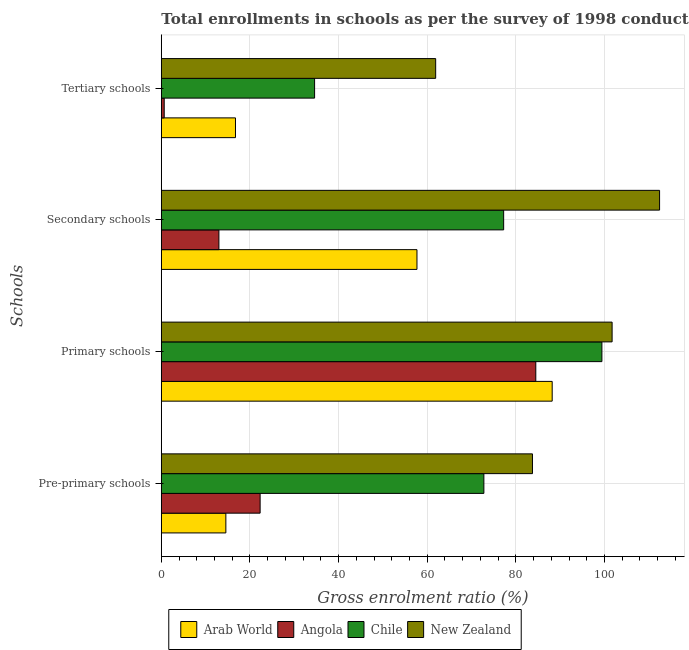Are the number of bars on each tick of the Y-axis equal?
Keep it short and to the point. Yes. How many bars are there on the 1st tick from the bottom?
Your answer should be compact. 4. What is the label of the 2nd group of bars from the top?
Make the answer very short. Secondary schools. What is the gross enrolment ratio in pre-primary schools in Angola?
Your answer should be very brief. 22.3. Across all countries, what is the maximum gross enrolment ratio in pre-primary schools?
Your answer should be compact. 83.75. Across all countries, what is the minimum gross enrolment ratio in primary schools?
Give a very brief answer. 84.5. In which country was the gross enrolment ratio in tertiary schools maximum?
Provide a short and direct response. New Zealand. In which country was the gross enrolment ratio in primary schools minimum?
Give a very brief answer. Angola. What is the total gross enrolment ratio in tertiary schools in the graph?
Your answer should be compact. 113.89. What is the difference between the gross enrolment ratio in tertiary schools in Arab World and that in Angola?
Give a very brief answer. 16.08. What is the difference between the gross enrolment ratio in tertiary schools in New Zealand and the gross enrolment ratio in primary schools in Chile?
Give a very brief answer. -37.51. What is the average gross enrolment ratio in pre-primary schools per country?
Make the answer very short. 48.35. What is the difference between the gross enrolment ratio in pre-primary schools and gross enrolment ratio in tertiary schools in Angola?
Provide a short and direct response. 21.64. In how many countries, is the gross enrolment ratio in pre-primary schools greater than 92 %?
Offer a terse response. 0. What is the ratio of the gross enrolment ratio in primary schools in New Zealand to that in Arab World?
Provide a succinct answer. 1.15. Is the gross enrolment ratio in secondary schools in New Zealand less than that in Chile?
Give a very brief answer. No. Is the difference between the gross enrolment ratio in primary schools in Angola and Arab World greater than the difference between the gross enrolment ratio in secondary schools in Angola and Arab World?
Your response must be concise. Yes. What is the difference between the highest and the second highest gross enrolment ratio in tertiary schools?
Your answer should be very brief. 27.32. What is the difference between the highest and the lowest gross enrolment ratio in secondary schools?
Your response must be concise. 99.44. In how many countries, is the gross enrolment ratio in primary schools greater than the average gross enrolment ratio in primary schools taken over all countries?
Keep it short and to the point. 2. Is it the case that in every country, the sum of the gross enrolment ratio in primary schools and gross enrolment ratio in secondary schools is greater than the sum of gross enrolment ratio in pre-primary schools and gross enrolment ratio in tertiary schools?
Provide a short and direct response. Yes. What does the 4th bar from the top in Primary schools represents?
Your answer should be very brief. Arab World. What does the 2nd bar from the bottom in Primary schools represents?
Your response must be concise. Angola. Is it the case that in every country, the sum of the gross enrolment ratio in pre-primary schools and gross enrolment ratio in primary schools is greater than the gross enrolment ratio in secondary schools?
Ensure brevity in your answer.  Yes. Are all the bars in the graph horizontal?
Your response must be concise. Yes. What is the difference between two consecutive major ticks on the X-axis?
Make the answer very short. 20. Does the graph contain grids?
Ensure brevity in your answer.  Yes. Where does the legend appear in the graph?
Make the answer very short. Bottom center. How many legend labels are there?
Ensure brevity in your answer.  4. How are the legend labels stacked?
Ensure brevity in your answer.  Horizontal. What is the title of the graph?
Your answer should be very brief. Total enrollments in schools as per the survey of 1998 conducted in different countries. What is the label or title of the X-axis?
Ensure brevity in your answer.  Gross enrolment ratio (%). What is the label or title of the Y-axis?
Offer a terse response. Schools. What is the Gross enrolment ratio (%) in Arab World in Pre-primary schools?
Ensure brevity in your answer.  14.56. What is the Gross enrolment ratio (%) of Angola in Pre-primary schools?
Your answer should be compact. 22.3. What is the Gross enrolment ratio (%) in Chile in Pre-primary schools?
Offer a terse response. 72.79. What is the Gross enrolment ratio (%) of New Zealand in Pre-primary schools?
Keep it short and to the point. 83.75. What is the Gross enrolment ratio (%) in Arab World in Primary schools?
Make the answer very short. 88.2. What is the Gross enrolment ratio (%) of Angola in Primary schools?
Give a very brief answer. 84.5. What is the Gross enrolment ratio (%) of Chile in Primary schools?
Provide a short and direct response. 99.42. What is the Gross enrolment ratio (%) in New Zealand in Primary schools?
Ensure brevity in your answer.  101.72. What is the Gross enrolment ratio (%) of Arab World in Secondary schools?
Offer a very short reply. 57.69. What is the Gross enrolment ratio (%) of Angola in Secondary schools?
Keep it short and to the point. 12.99. What is the Gross enrolment ratio (%) in Chile in Secondary schools?
Offer a very short reply. 77.25. What is the Gross enrolment ratio (%) in New Zealand in Secondary schools?
Your response must be concise. 112.43. What is the Gross enrolment ratio (%) in Arab World in Tertiary schools?
Give a very brief answer. 16.74. What is the Gross enrolment ratio (%) in Angola in Tertiary schools?
Your response must be concise. 0.65. What is the Gross enrolment ratio (%) in Chile in Tertiary schools?
Give a very brief answer. 34.59. What is the Gross enrolment ratio (%) of New Zealand in Tertiary schools?
Your answer should be very brief. 61.91. Across all Schools, what is the maximum Gross enrolment ratio (%) of Arab World?
Give a very brief answer. 88.2. Across all Schools, what is the maximum Gross enrolment ratio (%) in Angola?
Provide a short and direct response. 84.5. Across all Schools, what is the maximum Gross enrolment ratio (%) of Chile?
Keep it short and to the point. 99.42. Across all Schools, what is the maximum Gross enrolment ratio (%) of New Zealand?
Provide a short and direct response. 112.43. Across all Schools, what is the minimum Gross enrolment ratio (%) of Arab World?
Offer a terse response. 14.56. Across all Schools, what is the minimum Gross enrolment ratio (%) of Angola?
Your answer should be compact. 0.65. Across all Schools, what is the minimum Gross enrolment ratio (%) in Chile?
Provide a short and direct response. 34.59. Across all Schools, what is the minimum Gross enrolment ratio (%) in New Zealand?
Provide a succinct answer. 61.91. What is the total Gross enrolment ratio (%) of Arab World in the graph?
Provide a succinct answer. 177.19. What is the total Gross enrolment ratio (%) of Angola in the graph?
Provide a succinct answer. 120.45. What is the total Gross enrolment ratio (%) of Chile in the graph?
Your response must be concise. 284.04. What is the total Gross enrolment ratio (%) in New Zealand in the graph?
Your response must be concise. 359.81. What is the difference between the Gross enrolment ratio (%) in Arab World in Pre-primary schools and that in Primary schools?
Keep it short and to the point. -73.64. What is the difference between the Gross enrolment ratio (%) of Angola in Pre-primary schools and that in Primary schools?
Offer a very short reply. -62.2. What is the difference between the Gross enrolment ratio (%) in Chile in Pre-primary schools and that in Primary schools?
Your response must be concise. -26.63. What is the difference between the Gross enrolment ratio (%) of New Zealand in Pre-primary schools and that in Primary schools?
Ensure brevity in your answer.  -17.97. What is the difference between the Gross enrolment ratio (%) of Arab World in Pre-primary schools and that in Secondary schools?
Your answer should be compact. -43.12. What is the difference between the Gross enrolment ratio (%) of Angola in Pre-primary schools and that in Secondary schools?
Your answer should be compact. 9.3. What is the difference between the Gross enrolment ratio (%) of Chile in Pre-primary schools and that in Secondary schools?
Your answer should be very brief. -4.46. What is the difference between the Gross enrolment ratio (%) of New Zealand in Pre-primary schools and that in Secondary schools?
Offer a very short reply. -28.68. What is the difference between the Gross enrolment ratio (%) in Arab World in Pre-primary schools and that in Tertiary schools?
Provide a short and direct response. -2.17. What is the difference between the Gross enrolment ratio (%) of Angola in Pre-primary schools and that in Tertiary schools?
Offer a very short reply. 21.64. What is the difference between the Gross enrolment ratio (%) in Chile in Pre-primary schools and that in Tertiary schools?
Your answer should be very brief. 38.2. What is the difference between the Gross enrolment ratio (%) in New Zealand in Pre-primary schools and that in Tertiary schools?
Ensure brevity in your answer.  21.84. What is the difference between the Gross enrolment ratio (%) of Arab World in Primary schools and that in Secondary schools?
Offer a very short reply. 30.51. What is the difference between the Gross enrolment ratio (%) of Angola in Primary schools and that in Secondary schools?
Ensure brevity in your answer.  71.51. What is the difference between the Gross enrolment ratio (%) in Chile in Primary schools and that in Secondary schools?
Make the answer very short. 22.17. What is the difference between the Gross enrolment ratio (%) of New Zealand in Primary schools and that in Secondary schools?
Provide a short and direct response. -10.71. What is the difference between the Gross enrolment ratio (%) in Arab World in Primary schools and that in Tertiary schools?
Keep it short and to the point. 71.46. What is the difference between the Gross enrolment ratio (%) of Angola in Primary schools and that in Tertiary schools?
Keep it short and to the point. 83.85. What is the difference between the Gross enrolment ratio (%) in Chile in Primary schools and that in Tertiary schools?
Provide a short and direct response. 64.83. What is the difference between the Gross enrolment ratio (%) in New Zealand in Primary schools and that in Tertiary schools?
Your answer should be compact. 39.81. What is the difference between the Gross enrolment ratio (%) of Arab World in Secondary schools and that in Tertiary schools?
Provide a succinct answer. 40.95. What is the difference between the Gross enrolment ratio (%) of Angola in Secondary schools and that in Tertiary schools?
Your answer should be compact. 12.34. What is the difference between the Gross enrolment ratio (%) in Chile in Secondary schools and that in Tertiary schools?
Give a very brief answer. 42.66. What is the difference between the Gross enrolment ratio (%) of New Zealand in Secondary schools and that in Tertiary schools?
Offer a very short reply. 50.52. What is the difference between the Gross enrolment ratio (%) of Arab World in Pre-primary schools and the Gross enrolment ratio (%) of Angola in Primary schools?
Provide a short and direct response. -69.94. What is the difference between the Gross enrolment ratio (%) in Arab World in Pre-primary schools and the Gross enrolment ratio (%) in Chile in Primary schools?
Give a very brief answer. -84.85. What is the difference between the Gross enrolment ratio (%) of Arab World in Pre-primary schools and the Gross enrolment ratio (%) of New Zealand in Primary schools?
Your response must be concise. -87.15. What is the difference between the Gross enrolment ratio (%) in Angola in Pre-primary schools and the Gross enrolment ratio (%) in Chile in Primary schools?
Your answer should be very brief. -77.12. What is the difference between the Gross enrolment ratio (%) of Angola in Pre-primary schools and the Gross enrolment ratio (%) of New Zealand in Primary schools?
Keep it short and to the point. -79.42. What is the difference between the Gross enrolment ratio (%) in Chile in Pre-primary schools and the Gross enrolment ratio (%) in New Zealand in Primary schools?
Provide a short and direct response. -28.93. What is the difference between the Gross enrolment ratio (%) of Arab World in Pre-primary schools and the Gross enrolment ratio (%) of Angola in Secondary schools?
Your answer should be very brief. 1.57. What is the difference between the Gross enrolment ratio (%) of Arab World in Pre-primary schools and the Gross enrolment ratio (%) of Chile in Secondary schools?
Provide a short and direct response. -62.69. What is the difference between the Gross enrolment ratio (%) of Arab World in Pre-primary schools and the Gross enrolment ratio (%) of New Zealand in Secondary schools?
Make the answer very short. -97.87. What is the difference between the Gross enrolment ratio (%) in Angola in Pre-primary schools and the Gross enrolment ratio (%) in Chile in Secondary schools?
Your response must be concise. -54.95. What is the difference between the Gross enrolment ratio (%) in Angola in Pre-primary schools and the Gross enrolment ratio (%) in New Zealand in Secondary schools?
Your answer should be compact. -90.14. What is the difference between the Gross enrolment ratio (%) in Chile in Pre-primary schools and the Gross enrolment ratio (%) in New Zealand in Secondary schools?
Your response must be concise. -39.65. What is the difference between the Gross enrolment ratio (%) in Arab World in Pre-primary schools and the Gross enrolment ratio (%) in Angola in Tertiary schools?
Provide a short and direct response. 13.91. What is the difference between the Gross enrolment ratio (%) in Arab World in Pre-primary schools and the Gross enrolment ratio (%) in Chile in Tertiary schools?
Offer a terse response. -20.02. What is the difference between the Gross enrolment ratio (%) of Arab World in Pre-primary schools and the Gross enrolment ratio (%) of New Zealand in Tertiary schools?
Provide a short and direct response. -47.34. What is the difference between the Gross enrolment ratio (%) in Angola in Pre-primary schools and the Gross enrolment ratio (%) in Chile in Tertiary schools?
Offer a terse response. -12.29. What is the difference between the Gross enrolment ratio (%) of Angola in Pre-primary schools and the Gross enrolment ratio (%) of New Zealand in Tertiary schools?
Ensure brevity in your answer.  -39.61. What is the difference between the Gross enrolment ratio (%) in Chile in Pre-primary schools and the Gross enrolment ratio (%) in New Zealand in Tertiary schools?
Make the answer very short. 10.88. What is the difference between the Gross enrolment ratio (%) in Arab World in Primary schools and the Gross enrolment ratio (%) in Angola in Secondary schools?
Your response must be concise. 75.21. What is the difference between the Gross enrolment ratio (%) in Arab World in Primary schools and the Gross enrolment ratio (%) in Chile in Secondary schools?
Your answer should be very brief. 10.95. What is the difference between the Gross enrolment ratio (%) of Arab World in Primary schools and the Gross enrolment ratio (%) of New Zealand in Secondary schools?
Provide a short and direct response. -24.23. What is the difference between the Gross enrolment ratio (%) of Angola in Primary schools and the Gross enrolment ratio (%) of Chile in Secondary schools?
Make the answer very short. 7.25. What is the difference between the Gross enrolment ratio (%) in Angola in Primary schools and the Gross enrolment ratio (%) in New Zealand in Secondary schools?
Provide a short and direct response. -27.93. What is the difference between the Gross enrolment ratio (%) in Chile in Primary schools and the Gross enrolment ratio (%) in New Zealand in Secondary schools?
Your answer should be compact. -13.01. What is the difference between the Gross enrolment ratio (%) of Arab World in Primary schools and the Gross enrolment ratio (%) of Angola in Tertiary schools?
Your answer should be very brief. 87.55. What is the difference between the Gross enrolment ratio (%) of Arab World in Primary schools and the Gross enrolment ratio (%) of Chile in Tertiary schools?
Ensure brevity in your answer.  53.61. What is the difference between the Gross enrolment ratio (%) in Arab World in Primary schools and the Gross enrolment ratio (%) in New Zealand in Tertiary schools?
Your response must be concise. 26.29. What is the difference between the Gross enrolment ratio (%) in Angola in Primary schools and the Gross enrolment ratio (%) in Chile in Tertiary schools?
Keep it short and to the point. 49.92. What is the difference between the Gross enrolment ratio (%) of Angola in Primary schools and the Gross enrolment ratio (%) of New Zealand in Tertiary schools?
Ensure brevity in your answer.  22.59. What is the difference between the Gross enrolment ratio (%) in Chile in Primary schools and the Gross enrolment ratio (%) in New Zealand in Tertiary schools?
Give a very brief answer. 37.51. What is the difference between the Gross enrolment ratio (%) of Arab World in Secondary schools and the Gross enrolment ratio (%) of Angola in Tertiary schools?
Ensure brevity in your answer.  57.03. What is the difference between the Gross enrolment ratio (%) in Arab World in Secondary schools and the Gross enrolment ratio (%) in Chile in Tertiary schools?
Provide a succinct answer. 23.1. What is the difference between the Gross enrolment ratio (%) of Arab World in Secondary schools and the Gross enrolment ratio (%) of New Zealand in Tertiary schools?
Your response must be concise. -4.22. What is the difference between the Gross enrolment ratio (%) in Angola in Secondary schools and the Gross enrolment ratio (%) in Chile in Tertiary schools?
Provide a succinct answer. -21.59. What is the difference between the Gross enrolment ratio (%) in Angola in Secondary schools and the Gross enrolment ratio (%) in New Zealand in Tertiary schools?
Keep it short and to the point. -48.91. What is the difference between the Gross enrolment ratio (%) of Chile in Secondary schools and the Gross enrolment ratio (%) of New Zealand in Tertiary schools?
Offer a terse response. 15.34. What is the average Gross enrolment ratio (%) of Arab World per Schools?
Make the answer very short. 44.3. What is the average Gross enrolment ratio (%) of Angola per Schools?
Your answer should be compact. 30.11. What is the average Gross enrolment ratio (%) of Chile per Schools?
Provide a short and direct response. 71.01. What is the average Gross enrolment ratio (%) in New Zealand per Schools?
Offer a very short reply. 89.95. What is the difference between the Gross enrolment ratio (%) in Arab World and Gross enrolment ratio (%) in Angola in Pre-primary schools?
Give a very brief answer. -7.73. What is the difference between the Gross enrolment ratio (%) in Arab World and Gross enrolment ratio (%) in Chile in Pre-primary schools?
Ensure brevity in your answer.  -58.22. What is the difference between the Gross enrolment ratio (%) in Arab World and Gross enrolment ratio (%) in New Zealand in Pre-primary schools?
Your response must be concise. -69.18. What is the difference between the Gross enrolment ratio (%) of Angola and Gross enrolment ratio (%) of Chile in Pre-primary schools?
Offer a terse response. -50.49. What is the difference between the Gross enrolment ratio (%) of Angola and Gross enrolment ratio (%) of New Zealand in Pre-primary schools?
Ensure brevity in your answer.  -61.45. What is the difference between the Gross enrolment ratio (%) of Chile and Gross enrolment ratio (%) of New Zealand in Pre-primary schools?
Provide a succinct answer. -10.96. What is the difference between the Gross enrolment ratio (%) in Arab World and Gross enrolment ratio (%) in Angola in Primary schools?
Provide a succinct answer. 3.7. What is the difference between the Gross enrolment ratio (%) of Arab World and Gross enrolment ratio (%) of Chile in Primary schools?
Your response must be concise. -11.22. What is the difference between the Gross enrolment ratio (%) of Arab World and Gross enrolment ratio (%) of New Zealand in Primary schools?
Your answer should be very brief. -13.52. What is the difference between the Gross enrolment ratio (%) of Angola and Gross enrolment ratio (%) of Chile in Primary schools?
Give a very brief answer. -14.92. What is the difference between the Gross enrolment ratio (%) of Angola and Gross enrolment ratio (%) of New Zealand in Primary schools?
Give a very brief answer. -17.22. What is the difference between the Gross enrolment ratio (%) in Chile and Gross enrolment ratio (%) in New Zealand in Primary schools?
Make the answer very short. -2.3. What is the difference between the Gross enrolment ratio (%) of Arab World and Gross enrolment ratio (%) of Angola in Secondary schools?
Make the answer very short. 44.69. What is the difference between the Gross enrolment ratio (%) in Arab World and Gross enrolment ratio (%) in Chile in Secondary schools?
Provide a short and direct response. -19.56. What is the difference between the Gross enrolment ratio (%) of Arab World and Gross enrolment ratio (%) of New Zealand in Secondary schools?
Offer a very short reply. -54.75. What is the difference between the Gross enrolment ratio (%) in Angola and Gross enrolment ratio (%) in Chile in Secondary schools?
Your answer should be very brief. -64.26. What is the difference between the Gross enrolment ratio (%) of Angola and Gross enrolment ratio (%) of New Zealand in Secondary schools?
Offer a very short reply. -99.44. What is the difference between the Gross enrolment ratio (%) in Chile and Gross enrolment ratio (%) in New Zealand in Secondary schools?
Your answer should be very brief. -35.18. What is the difference between the Gross enrolment ratio (%) in Arab World and Gross enrolment ratio (%) in Angola in Tertiary schools?
Your response must be concise. 16.08. What is the difference between the Gross enrolment ratio (%) of Arab World and Gross enrolment ratio (%) of Chile in Tertiary schools?
Ensure brevity in your answer.  -17.85. What is the difference between the Gross enrolment ratio (%) in Arab World and Gross enrolment ratio (%) in New Zealand in Tertiary schools?
Give a very brief answer. -45.17. What is the difference between the Gross enrolment ratio (%) of Angola and Gross enrolment ratio (%) of Chile in Tertiary schools?
Ensure brevity in your answer.  -33.93. What is the difference between the Gross enrolment ratio (%) in Angola and Gross enrolment ratio (%) in New Zealand in Tertiary schools?
Your response must be concise. -61.25. What is the difference between the Gross enrolment ratio (%) in Chile and Gross enrolment ratio (%) in New Zealand in Tertiary schools?
Keep it short and to the point. -27.32. What is the ratio of the Gross enrolment ratio (%) in Arab World in Pre-primary schools to that in Primary schools?
Offer a very short reply. 0.17. What is the ratio of the Gross enrolment ratio (%) of Angola in Pre-primary schools to that in Primary schools?
Offer a terse response. 0.26. What is the ratio of the Gross enrolment ratio (%) of Chile in Pre-primary schools to that in Primary schools?
Offer a terse response. 0.73. What is the ratio of the Gross enrolment ratio (%) of New Zealand in Pre-primary schools to that in Primary schools?
Offer a very short reply. 0.82. What is the ratio of the Gross enrolment ratio (%) of Arab World in Pre-primary schools to that in Secondary schools?
Offer a terse response. 0.25. What is the ratio of the Gross enrolment ratio (%) of Angola in Pre-primary schools to that in Secondary schools?
Provide a succinct answer. 1.72. What is the ratio of the Gross enrolment ratio (%) in Chile in Pre-primary schools to that in Secondary schools?
Make the answer very short. 0.94. What is the ratio of the Gross enrolment ratio (%) of New Zealand in Pre-primary schools to that in Secondary schools?
Offer a very short reply. 0.74. What is the ratio of the Gross enrolment ratio (%) in Arab World in Pre-primary schools to that in Tertiary schools?
Your response must be concise. 0.87. What is the ratio of the Gross enrolment ratio (%) of Angola in Pre-primary schools to that in Tertiary schools?
Provide a succinct answer. 34.12. What is the ratio of the Gross enrolment ratio (%) of Chile in Pre-primary schools to that in Tertiary schools?
Your answer should be compact. 2.1. What is the ratio of the Gross enrolment ratio (%) of New Zealand in Pre-primary schools to that in Tertiary schools?
Give a very brief answer. 1.35. What is the ratio of the Gross enrolment ratio (%) in Arab World in Primary schools to that in Secondary schools?
Give a very brief answer. 1.53. What is the ratio of the Gross enrolment ratio (%) of Angola in Primary schools to that in Secondary schools?
Ensure brevity in your answer.  6.5. What is the ratio of the Gross enrolment ratio (%) in Chile in Primary schools to that in Secondary schools?
Offer a terse response. 1.29. What is the ratio of the Gross enrolment ratio (%) in New Zealand in Primary schools to that in Secondary schools?
Offer a terse response. 0.9. What is the ratio of the Gross enrolment ratio (%) of Arab World in Primary schools to that in Tertiary schools?
Your answer should be compact. 5.27. What is the ratio of the Gross enrolment ratio (%) in Angola in Primary schools to that in Tertiary schools?
Offer a terse response. 129.29. What is the ratio of the Gross enrolment ratio (%) in Chile in Primary schools to that in Tertiary schools?
Offer a very short reply. 2.87. What is the ratio of the Gross enrolment ratio (%) of New Zealand in Primary schools to that in Tertiary schools?
Provide a succinct answer. 1.64. What is the ratio of the Gross enrolment ratio (%) in Arab World in Secondary schools to that in Tertiary schools?
Provide a short and direct response. 3.45. What is the ratio of the Gross enrolment ratio (%) of Angola in Secondary schools to that in Tertiary schools?
Your response must be concise. 19.88. What is the ratio of the Gross enrolment ratio (%) in Chile in Secondary schools to that in Tertiary schools?
Your response must be concise. 2.23. What is the ratio of the Gross enrolment ratio (%) of New Zealand in Secondary schools to that in Tertiary schools?
Your answer should be compact. 1.82. What is the difference between the highest and the second highest Gross enrolment ratio (%) of Arab World?
Your answer should be very brief. 30.51. What is the difference between the highest and the second highest Gross enrolment ratio (%) of Angola?
Your response must be concise. 62.2. What is the difference between the highest and the second highest Gross enrolment ratio (%) of Chile?
Make the answer very short. 22.17. What is the difference between the highest and the second highest Gross enrolment ratio (%) of New Zealand?
Make the answer very short. 10.71. What is the difference between the highest and the lowest Gross enrolment ratio (%) in Arab World?
Your answer should be compact. 73.64. What is the difference between the highest and the lowest Gross enrolment ratio (%) of Angola?
Your answer should be very brief. 83.85. What is the difference between the highest and the lowest Gross enrolment ratio (%) of Chile?
Provide a short and direct response. 64.83. What is the difference between the highest and the lowest Gross enrolment ratio (%) in New Zealand?
Your answer should be compact. 50.52. 